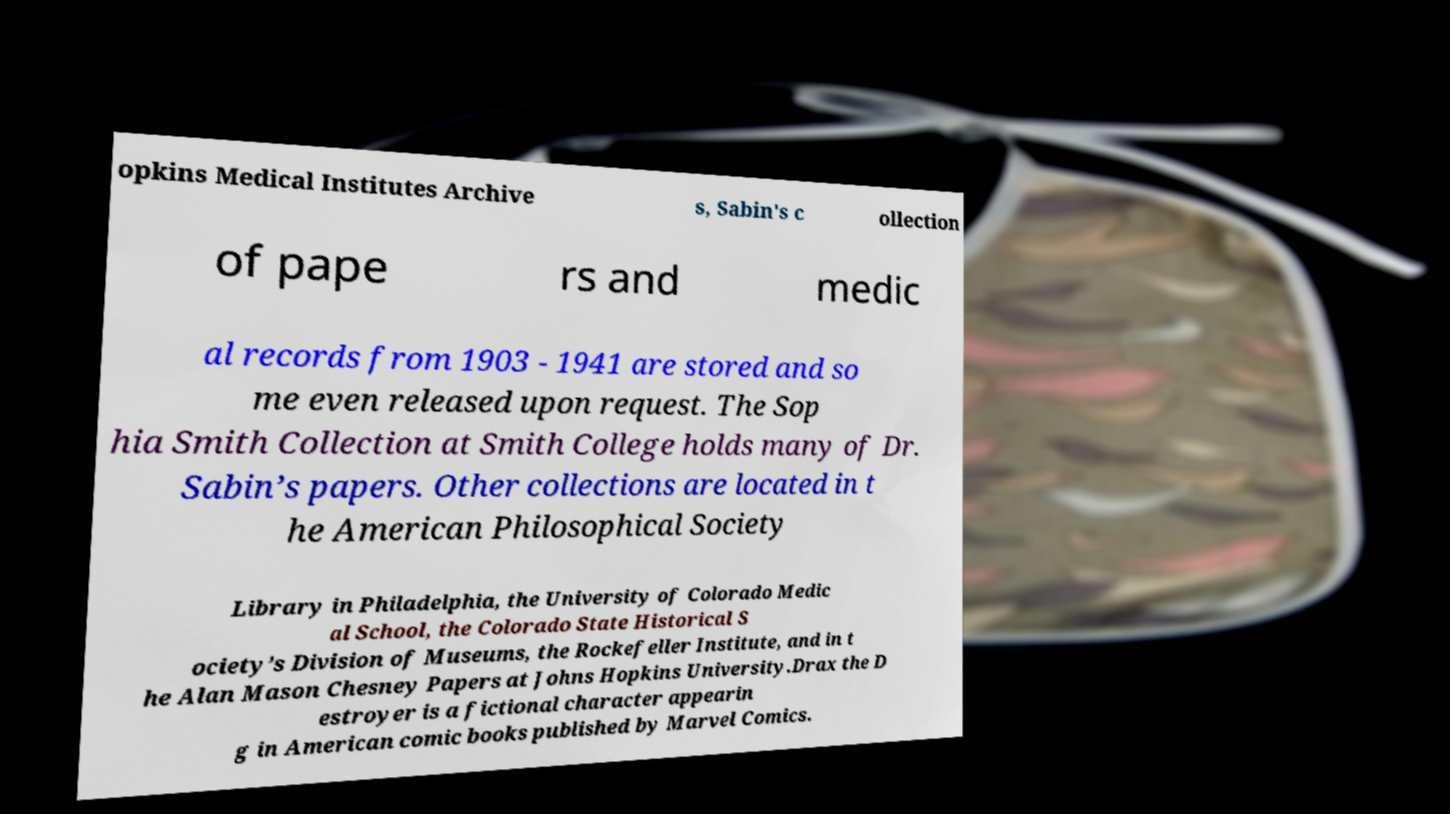I need the written content from this picture converted into text. Can you do that? opkins Medical Institutes Archive s, Sabin's c ollection of pape rs and medic al records from 1903 - 1941 are stored and so me even released upon request. The Sop hia Smith Collection at Smith College holds many of Dr. Sabin’s papers. Other collections are located in t he American Philosophical Society Library in Philadelphia, the University of Colorado Medic al School, the Colorado State Historical S ociety’s Division of Museums, the Rockefeller Institute, and in t he Alan Mason Chesney Papers at Johns Hopkins University.Drax the D estroyer is a fictional character appearin g in American comic books published by Marvel Comics. 